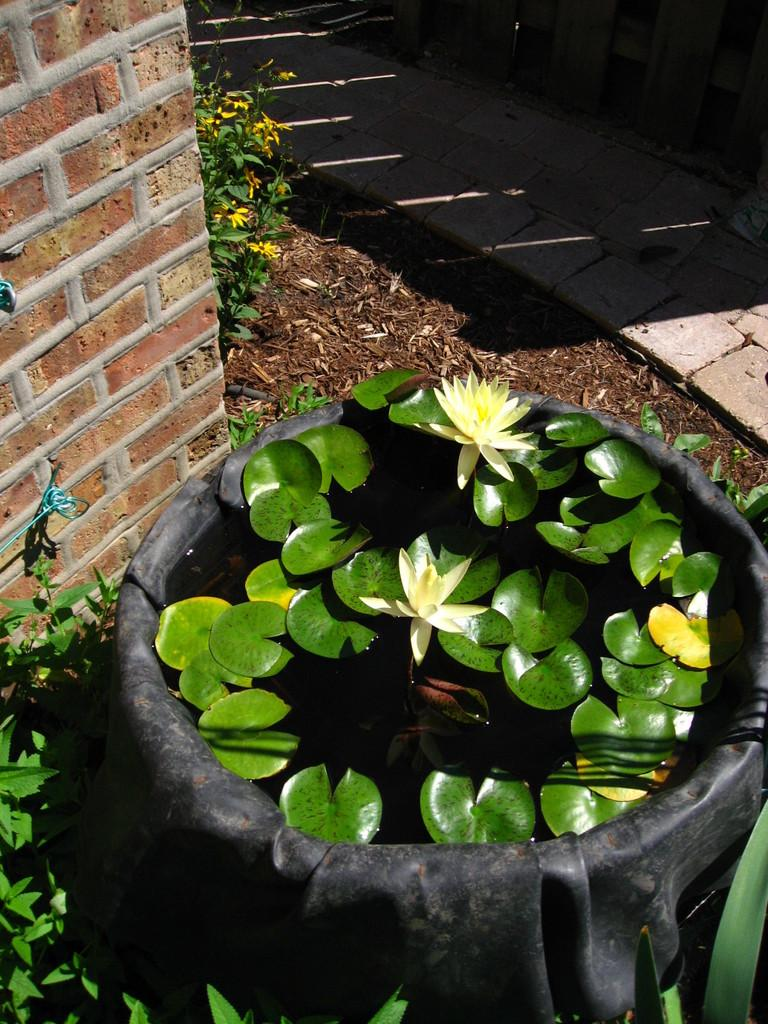What is the main object in the image? There is a tub in the image. What is inside the tub? There are water plants and flowers in the tub. Are there any plants outside the tub? Yes, there are plants around the tub. What can be seen in the background of the image? There is a wall and a land beside the wall. Is there any path visible in the image? Yes, there is a path in the image. Can you tell me how the guide is helping the visitors in the image? There is no guide present in the image; it features a tub with water plants, flowers, and plants around it. What type of frame is used to hold the stream in the image? There is no stream or frame present in the image. 